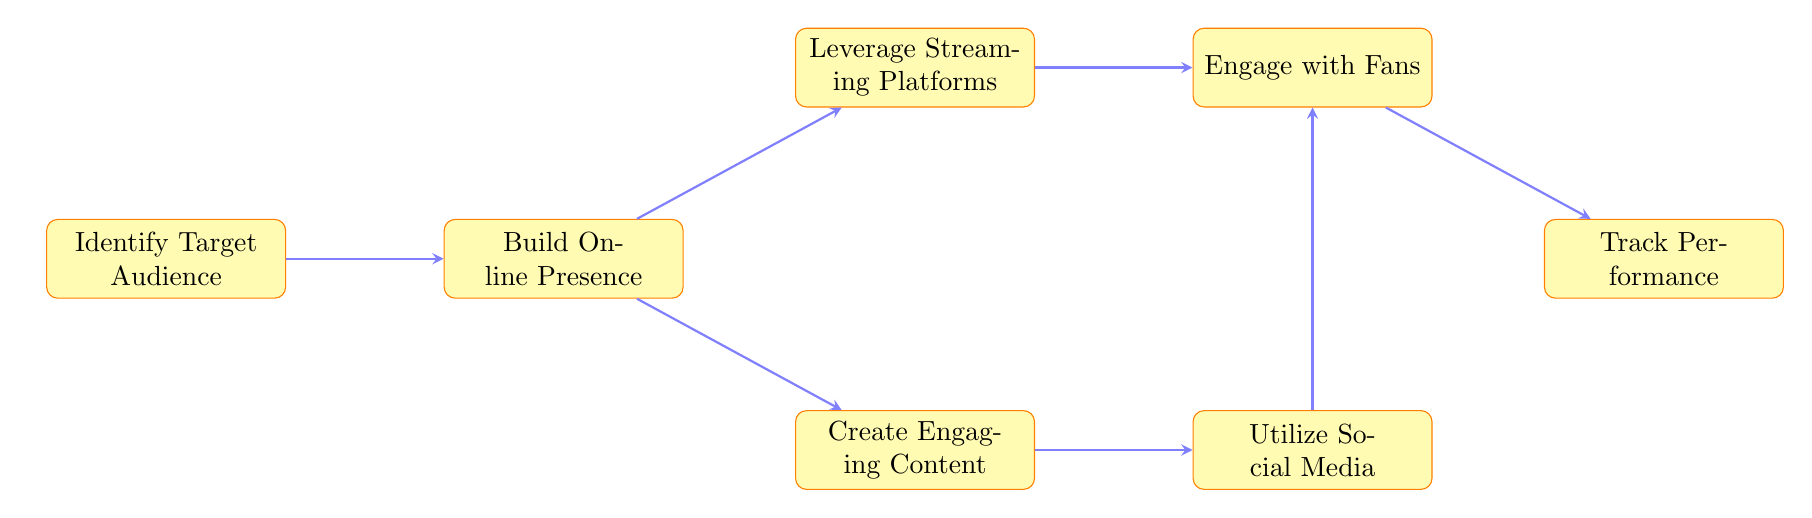What's the first step in the marketing strategy? The diagram starts with the node labeled "Identify Target Audience," indicating that this is the first step.
Answer: Identify Target Audience How many nodes are in the diagram? By counting the nodes in the diagram, we see there are a total of seven distinct steps or elements.
Answer: 7 Which node comes after "Build Online Presence"? The node that follows "Build Online Presence" branches into two options: "Create Engaging Content" and "Leverage Streaming Platforms." However, the next sequential node in terms of the flow is "Create Engaging Content."
Answer: Create Engaging Content What does "Engage with Fans" lead to? "Engage with Fans" has a direct arrow leading to the "Track Performance" node, indicating it is the next step after engaging with fans.
Answer: Track Performance Describe the relationship between "Utilize Social Media" and "Engage with Fans." "Utilize Social Media" is a preceding step that branches into a direct relationship with the "Engage with Fans" node; therefore, engaging with fans follows from utilizing social media.
Answer: Direct relationship What action is required after "Track Performance"? The "Track Performance" node does not lead to another action or node, indicating this is likely the final step where performance is assessed.
Answer: None Which node serves as a branching point to two actions? The "Build Online Presence" node serves as a branching point, leading to both "Create Engaging Content" and "Leverage Streaming Platforms."
Answer: Build Online Presence 